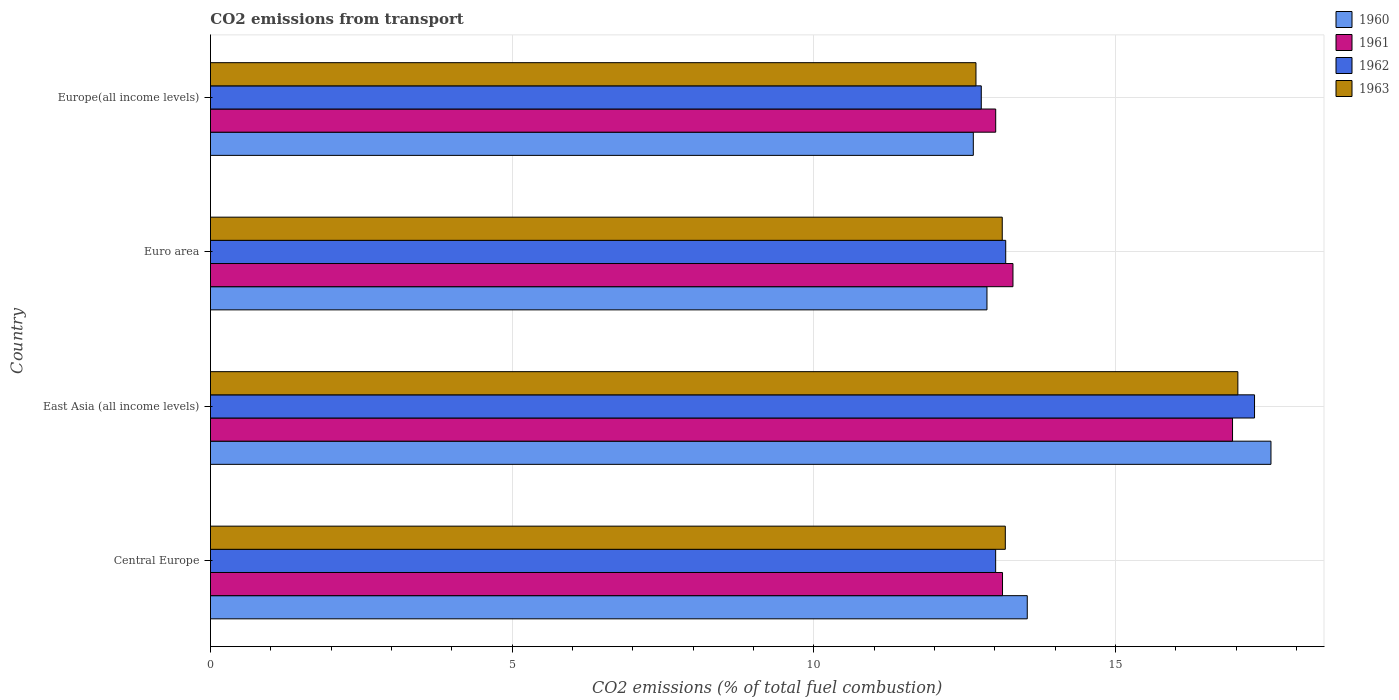Are the number of bars per tick equal to the number of legend labels?
Your answer should be very brief. Yes. How many bars are there on the 2nd tick from the bottom?
Make the answer very short. 4. What is the label of the 4th group of bars from the top?
Provide a short and direct response. Central Europe. In how many cases, is the number of bars for a given country not equal to the number of legend labels?
Your answer should be compact. 0. What is the total CO2 emitted in 1962 in Europe(all income levels)?
Your answer should be very brief. 12.78. Across all countries, what is the maximum total CO2 emitted in 1963?
Make the answer very short. 17.03. Across all countries, what is the minimum total CO2 emitted in 1962?
Ensure brevity in your answer.  12.78. In which country was the total CO2 emitted in 1960 maximum?
Your answer should be compact. East Asia (all income levels). In which country was the total CO2 emitted in 1963 minimum?
Your answer should be very brief. Europe(all income levels). What is the total total CO2 emitted in 1961 in the graph?
Make the answer very short. 56.38. What is the difference between the total CO2 emitted in 1961 in Central Europe and that in Europe(all income levels)?
Your answer should be very brief. 0.11. What is the difference between the total CO2 emitted in 1963 in Euro area and the total CO2 emitted in 1961 in Europe(all income levels)?
Your answer should be compact. 0.11. What is the average total CO2 emitted in 1963 per country?
Your answer should be compact. 14. What is the difference between the total CO2 emitted in 1961 and total CO2 emitted in 1962 in East Asia (all income levels)?
Provide a short and direct response. -0.36. In how many countries, is the total CO2 emitted in 1962 greater than 4 ?
Offer a terse response. 4. What is the ratio of the total CO2 emitted in 1961 in Euro area to that in Europe(all income levels)?
Your answer should be compact. 1.02. Is the total CO2 emitted in 1963 in East Asia (all income levels) less than that in Europe(all income levels)?
Ensure brevity in your answer.  No. What is the difference between the highest and the second highest total CO2 emitted in 1961?
Offer a terse response. 3.64. What is the difference between the highest and the lowest total CO2 emitted in 1961?
Your response must be concise. 3.93. In how many countries, is the total CO2 emitted in 1963 greater than the average total CO2 emitted in 1963 taken over all countries?
Give a very brief answer. 1. Is the sum of the total CO2 emitted in 1963 in East Asia (all income levels) and Europe(all income levels) greater than the maximum total CO2 emitted in 1961 across all countries?
Offer a very short reply. Yes. Does the graph contain grids?
Ensure brevity in your answer.  Yes. Where does the legend appear in the graph?
Make the answer very short. Top right. What is the title of the graph?
Your answer should be compact. CO2 emissions from transport. What is the label or title of the X-axis?
Your answer should be very brief. CO2 emissions (% of total fuel combustion). What is the label or title of the Y-axis?
Offer a very short reply. Country. What is the CO2 emissions (% of total fuel combustion) of 1960 in Central Europe?
Make the answer very short. 13.54. What is the CO2 emissions (% of total fuel combustion) of 1961 in Central Europe?
Offer a terse response. 13.13. What is the CO2 emissions (% of total fuel combustion) of 1962 in Central Europe?
Offer a terse response. 13.01. What is the CO2 emissions (% of total fuel combustion) in 1963 in Central Europe?
Make the answer very short. 13.17. What is the CO2 emissions (% of total fuel combustion) of 1960 in East Asia (all income levels)?
Your answer should be compact. 17.58. What is the CO2 emissions (% of total fuel combustion) of 1961 in East Asia (all income levels)?
Keep it short and to the point. 16.94. What is the CO2 emissions (% of total fuel combustion) in 1962 in East Asia (all income levels)?
Your answer should be compact. 17.3. What is the CO2 emissions (% of total fuel combustion) of 1963 in East Asia (all income levels)?
Your response must be concise. 17.03. What is the CO2 emissions (% of total fuel combustion) in 1960 in Euro area?
Offer a terse response. 12.87. What is the CO2 emissions (% of total fuel combustion) in 1961 in Euro area?
Provide a short and direct response. 13.3. What is the CO2 emissions (% of total fuel combustion) of 1962 in Euro area?
Your response must be concise. 13.18. What is the CO2 emissions (% of total fuel combustion) of 1963 in Euro area?
Keep it short and to the point. 13.12. What is the CO2 emissions (% of total fuel combustion) in 1960 in Europe(all income levels)?
Offer a very short reply. 12.64. What is the CO2 emissions (% of total fuel combustion) in 1961 in Europe(all income levels)?
Provide a succinct answer. 13.01. What is the CO2 emissions (% of total fuel combustion) of 1962 in Europe(all income levels)?
Give a very brief answer. 12.78. What is the CO2 emissions (% of total fuel combustion) of 1963 in Europe(all income levels)?
Your response must be concise. 12.69. Across all countries, what is the maximum CO2 emissions (% of total fuel combustion) of 1960?
Provide a succinct answer. 17.58. Across all countries, what is the maximum CO2 emissions (% of total fuel combustion) in 1961?
Your answer should be compact. 16.94. Across all countries, what is the maximum CO2 emissions (% of total fuel combustion) of 1962?
Your answer should be very brief. 17.3. Across all countries, what is the maximum CO2 emissions (% of total fuel combustion) in 1963?
Give a very brief answer. 17.03. Across all countries, what is the minimum CO2 emissions (% of total fuel combustion) of 1960?
Your answer should be very brief. 12.64. Across all countries, what is the minimum CO2 emissions (% of total fuel combustion) of 1961?
Keep it short and to the point. 13.01. Across all countries, what is the minimum CO2 emissions (% of total fuel combustion) of 1962?
Offer a terse response. 12.78. Across all countries, what is the minimum CO2 emissions (% of total fuel combustion) in 1963?
Provide a short and direct response. 12.69. What is the total CO2 emissions (% of total fuel combustion) of 1960 in the graph?
Provide a short and direct response. 56.63. What is the total CO2 emissions (% of total fuel combustion) of 1961 in the graph?
Provide a succinct answer. 56.38. What is the total CO2 emissions (% of total fuel combustion) in 1962 in the graph?
Provide a succinct answer. 56.28. What is the total CO2 emissions (% of total fuel combustion) of 1963 in the graph?
Make the answer very short. 56.01. What is the difference between the CO2 emissions (% of total fuel combustion) of 1960 in Central Europe and that in East Asia (all income levels)?
Your answer should be very brief. -4.04. What is the difference between the CO2 emissions (% of total fuel combustion) in 1961 in Central Europe and that in East Asia (all income levels)?
Offer a terse response. -3.81. What is the difference between the CO2 emissions (% of total fuel combustion) of 1962 in Central Europe and that in East Asia (all income levels)?
Your response must be concise. -4.29. What is the difference between the CO2 emissions (% of total fuel combustion) of 1963 in Central Europe and that in East Asia (all income levels)?
Offer a terse response. -3.85. What is the difference between the CO2 emissions (% of total fuel combustion) in 1960 in Central Europe and that in Euro area?
Your answer should be compact. 0.67. What is the difference between the CO2 emissions (% of total fuel combustion) in 1961 in Central Europe and that in Euro area?
Your answer should be compact. -0.17. What is the difference between the CO2 emissions (% of total fuel combustion) of 1962 in Central Europe and that in Euro area?
Offer a terse response. -0.17. What is the difference between the CO2 emissions (% of total fuel combustion) of 1963 in Central Europe and that in Euro area?
Ensure brevity in your answer.  0.05. What is the difference between the CO2 emissions (% of total fuel combustion) in 1960 in Central Europe and that in Europe(all income levels)?
Provide a short and direct response. 0.89. What is the difference between the CO2 emissions (% of total fuel combustion) in 1961 in Central Europe and that in Europe(all income levels)?
Give a very brief answer. 0.11. What is the difference between the CO2 emissions (% of total fuel combustion) of 1962 in Central Europe and that in Europe(all income levels)?
Keep it short and to the point. 0.24. What is the difference between the CO2 emissions (% of total fuel combustion) of 1963 in Central Europe and that in Europe(all income levels)?
Offer a very short reply. 0.49. What is the difference between the CO2 emissions (% of total fuel combustion) in 1960 in East Asia (all income levels) and that in Euro area?
Provide a succinct answer. 4.71. What is the difference between the CO2 emissions (% of total fuel combustion) in 1961 in East Asia (all income levels) and that in Euro area?
Offer a very short reply. 3.64. What is the difference between the CO2 emissions (% of total fuel combustion) in 1962 in East Asia (all income levels) and that in Euro area?
Your answer should be very brief. 4.12. What is the difference between the CO2 emissions (% of total fuel combustion) in 1963 in East Asia (all income levels) and that in Euro area?
Provide a succinct answer. 3.9. What is the difference between the CO2 emissions (% of total fuel combustion) in 1960 in East Asia (all income levels) and that in Europe(all income levels)?
Offer a very short reply. 4.93. What is the difference between the CO2 emissions (% of total fuel combustion) in 1961 in East Asia (all income levels) and that in Europe(all income levels)?
Offer a very short reply. 3.93. What is the difference between the CO2 emissions (% of total fuel combustion) of 1962 in East Asia (all income levels) and that in Europe(all income levels)?
Provide a short and direct response. 4.53. What is the difference between the CO2 emissions (% of total fuel combustion) of 1963 in East Asia (all income levels) and that in Europe(all income levels)?
Ensure brevity in your answer.  4.34. What is the difference between the CO2 emissions (% of total fuel combustion) of 1960 in Euro area and that in Europe(all income levels)?
Ensure brevity in your answer.  0.23. What is the difference between the CO2 emissions (% of total fuel combustion) of 1961 in Euro area and that in Europe(all income levels)?
Offer a very short reply. 0.29. What is the difference between the CO2 emissions (% of total fuel combustion) in 1962 in Euro area and that in Europe(all income levels)?
Offer a terse response. 0.41. What is the difference between the CO2 emissions (% of total fuel combustion) of 1963 in Euro area and that in Europe(all income levels)?
Your response must be concise. 0.44. What is the difference between the CO2 emissions (% of total fuel combustion) in 1960 in Central Europe and the CO2 emissions (% of total fuel combustion) in 1961 in East Asia (all income levels)?
Your response must be concise. -3.4. What is the difference between the CO2 emissions (% of total fuel combustion) of 1960 in Central Europe and the CO2 emissions (% of total fuel combustion) of 1962 in East Asia (all income levels)?
Make the answer very short. -3.77. What is the difference between the CO2 emissions (% of total fuel combustion) of 1960 in Central Europe and the CO2 emissions (% of total fuel combustion) of 1963 in East Asia (all income levels)?
Ensure brevity in your answer.  -3.49. What is the difference between the CO2 emissions (% of total fuel combustion) in 1961 in Central Europe and the CO2 emissions (% of total fuel combustion) in 1962 in East Asia (all income levels)?
Your answer should be compact. -4.18. What is the difference between the CO2 emissions (% of total fuel combustion) of 1961 in Central Europe and the CO2 emissions (% of total fuel combustion) of 1963 in East Asia (all income levels)?
Provide a succinct answer. -3.9. What is the difference between the CO2 emissions (% of total fuel combustion) in 1962 in Central Europe and the CO2 emissions (% of total fuel combustion) in 1963 in East Asia (all income levels)?
Your answer should be very brief. -4.01. What is the difference between the CO2 emissions (% of total fuel combustion) of 1960 in Central Europe and the CO2 emissions (% of total fuel combustion) of 1961 in Euro area?
Your response must be concise. 0.24. What is the difference between the CO2 emissions (% of total fuel combustion) of 1960 in Central Europe and the CO2 emissions (% of total fuel combustion) of 1962 in Euro area?
Your answer should be very brief. 0.36. What is the difference between the CO2 emissions (% of total fuel combustion) in 1960 in Central Europe and the CO2 emissions (% of total fuel combustion) in 1963 in Euro area?
Provide a short and direct response. 0.41. What is the difference between the CO2 emissions (% of total fuel combustion) of 1961 in Central Europe and the CO2 emissions (% of total fuel combustion) of 1962 in Euro area?
Provide a short and direct response. -0.05. What is the difference between the CO2 emissions (% of total fuel combustion) in 1961 in Central Europe and the CO2 emissions (% of total fuel combustion) in 1963 in Euro area?
Make the answer very short. 0. What is the difference between the CO2 emissions (% of total fuel combustion) in 1962 in Central Europe and the CO2 emissions (% of total fuel combustion) in 1963 in Euro area?
Provide a short and direct response. -0.11. What is the difference between the CO2 emissions (% of total fuel combustion) in 1960 in Central Europe and the CO2 emissions (% of total fuel combustion) in 1961 in Europe(all income levels)?
Keep it short and to the point. 0.52. What is the difference between the CO2 emissions (% of total fuel combustion) in 1960 in Central Europe and the CO2 emissions (% of total fuel combustion) in 1962 in Europe(all income levels)?
Provide a short and direct response. 0.76. What is the difference between the CO2 emissions (% of total fuel combustion) of 1960 in Central Europe and the CO2 emissions (% of total fuel combustion) of 1963 in Europe(all income levels)?
Ensure brevity in your answer.  0.85. What is the difference between the CO2 emissions (% of total fuel combustion) of 1961 in Central Europe and the CO2 emissions (% of total fuel combustion) of 1962 in Europe(all income levels)?
Your answer should be very brief. 0.35. What is the difference between the CO2 emissions (% of total fuel combustion) in 1961 in Central Europe and the CO2 emissions (% of total fuel combustion) in 1963 in Europe(all income levels)?
Make the answer very short. 0.44. What is the difference between the CO2 emissions (% of total fuel combustion) of 1962 in Central Europe and the CO2 emissions (% of total fuel combustion) of 1963 in Europe(all income levels)?
Offer a terse response. 0.33. What is the difference between the CO2 emissions (% of total fuel combustion) of 1960 in East Asia (all income levels) and the CO2 emissions (% of total fuel combustion) of 1961 in Euro area?
Provide a succinct answer. 4.28. What is the difference between the CO2 emissions (% of total fuel combustion) of 1960 in East Asia (all income levels) and the CO2 emissions (% of total fuel combustion) of 1962 in Euro area?
Provide a short and direct response. 4.4. What is the difference between the CO2 emissions (% of total fuel combustion) in 1960 in East Asia (all income levels) and the CO2 emissions (% of total fuel combustion) in 1963 in Euro area?
Give a very brief answer. 4.45. What is the difference between the CO2 emissions (% of total fuel combustion) in 1961 in East Asia (all income levels) and the CO2 emissions (% of total fuel combustion) in 1962 in Euro area?
Make the answer very short. 3.76. What is the difference between the CO2 emissions (% of total fuel combustion) of 1961 in East Asia (all income levels) and the CO2 emissions (% of total fuel combustion) of 1963 in Euro area?
Your response must be concise. 3.82. What is the difference between the CO2 emissions (% of total fuel combustion) of 1962 in East Asia (all income levels) and the CO2 emissions (% of total fuel combustion) of 1963 in Euro area?
Provide a short and direct response. 4.18. What is the difference between the CO2 emissions (% of total fuel combustion) of 1960 in East Asia (all income levels) and the CO2 emissions (% of total fuel combustion) of 1961 in Europe(all income levels)?
Your answer should be compact. 4.56. What is the difference between the CO2 emissions (% of total fuel combustion) of 1960 in East Asia (all income levels) and the CO2 emissions (% of total fuel combustion) of 1962 in Europe(all income levels)?
Keep it short and to the point. 4.8. What is the difference between the CO2 emissions (% of total fuel combustion) in 1960 in East Asia (all income levels) and the CO2 emissions (% of total fuel combustion) in 1963 in Europe(all income levels)?
Provide a succinct answer. 4.89. What is the difference between the CO2 emissions (% of total fuel combustion) of 1961 in East Asia (all income levels) and the CO2 emissions (% of total fuel combustion) of 1962 in Europe(all income levels)?
Your answer should be very brief. 4.16. What is the difference between the CO2 emissions (% of total fuel combustion) of 1961 in East Asia (all income levels) and the CO2 emissions (% of total fuel combustion) of 1963 in Europe(all income levels)?
Offer a terse response. 4.25. What is the difference between the CO2 emissions (% of total fuel combustion) of 1962 in East Asia (all income levels) and the CO2 emissions (% of total fuel combustion) of 1963 in Europe(all income levels)?
Your answer should be compact. 4.62. What is the difference between the CO2 emissions (% of total fuel combustion) of 1960 in Euro area and the CO2 emissions (% of total fuel combustion) of 1961 in Europe(all income levels)?
Offer a very short reply. -0.14. What is the difference between the CO2 emissions (% of total fuel combustion) in 1960 in Euro area and the CO2 emissions (% of total fuel combustion) in 1962 in Europe(all income levels)?
Provide a short and direct response. 0.09. What is the difference between the CO2 emissions (% of total fuel combustion) in 1960 in Euro area and the CO2 emissions (% of total fuel combustion) in 1963 in Europe(all income levels)?
Offer a terse response. 0.18. What is the difference between the CO2 emissions (% of total fuel combustion) in 1961 in Euro area and the CO2 emissions (% of total fuel combustion) in 1962 in Europe(all income levels)?
Give a very brief answer. 0.53. What is the difference between the CO2 emissions (% of total fuel combustion) in 1961 in Euro area and the CO2 emissions (% of total fuel combustion) in 1963 in Europe(all income levels)?
Provide a succinct answer. 0.61. What is the difference between the CO2 emissions (% of total fuel combustion) of 1962 in Euro area and the CO2 emissions (% of total fuel combustion) of 1963 in Europe(all income levels)?
Provide a short and direct response. 0.49. What is the average CO2 emissions (% of total fuel combustion) in 1960 per country?
Provide a short and direct response. 14.16. What is the average CO2 emissions (% of total fuel combustion) in 1961 per country?
Offer a terse response. 14.1. What is the average CO2 emissions (% of total fuel combustion) in 1962 per country?
Offer a very short reply. 14.07. What is the average CO2 emissions (% of total fuel combustion) of 1963 per country?
Your response must be concise. 14. What is the difference between the CO2 emissions (% of total fuel combustion) of 1960 and CO2 emissions (% of total fuel combustion) of 1961 in Central Europe?
Your answer should be compact. 0.41. What is the difference between the CO2 emissions (% of total fuel combustion) of 1960 and CO2 emissions (% of total fuel combustion) of 1962 in Central Europe?
Keep it short and to the point. 0.52. What is the difference between the CO2 emissions (% of total fuel combustion) in 1960 and CO2 emissions (% of total fuel combustion) in 1963 in Central Europe?
Your answer should be compact. 0.36. What is the difference between the CO2 emissions (% of total fuel combustion) in 1961 and CO2 emissions (% of total fuel combustion) in 1962 in Central Europe?
Your answer should be very brief. 0.11. What is the difference between the CO2 emissions (% of total fuel combustion) in 1961 and CO2 emissions (% of total fuel combustion) in 1963 in Central Europe?
Ensure brevity in your answer.  -0.05. What is the difference between the CO2 emissions (% of total fuel combustion) of 1962 and CO2 emissions (% of total fuel combustion) of 1963 in Central Europe?
Make the answer very short. -0.16. What is the difference between the CO2 emissions (% of total fuel combustion) in 1960 and CO2 emissions (% of total fuel combustion) in 1961 in East Asia (all income levels)?
Ensure brevity in your answer.  0.64. What is the difference between the CO2 emissions (% of total fuel combustion) of 1960 and CO2 emissions (% of total fuel combustion) of 1962 in East Asia (all income levels)?
Offer a very short reply. 0.27. What is the difference between the CO2 emissions (% of total fuel combustion) of 1960 and CO2 emissions (% of total fuel combustion) of 1963 in East Asia (all income levels)?
Offer a terse response. 0.55. What is the difference between the CO2 emissions (% of total fuel combustion) in 1961 and CO2 emissions (% of total fuel combustion) in 1962 in East Asia (all income levels)?
Offer a terse response. -0.36. What is the difference between the CO2 emissions (% of total fuel combustion) in 1961 and CO2 emissions (% of total fuel combustion) in 1963 in East Asia (all income levels)?
Give a very brief answer. -0.09. What is the difference between the CO2 emissions (% of total fuel combustion) of 1962 and CO2 emissions (% of total fuel combustion) of 1963 in East Asia (all income levels)?
Make the answer very short. 0.28. What is the difference between the CO2 emissions (% of total fuel combustion) in 1960 and CO2 emissions (% of total fuel combustion) in 1961 in Euro area?
Give a very brief answer. -0.43. What is the difference between the CO2 emissions (% of total fuel combustion) in 1960 and CO2 emissions (% of total fuel combustion) in 1962 in Euro area?
Your answer should be compact. -0.31. What is the difference between the CO2 emissions (% of total fuel combustion) in 1960 and CO2 emissions (% of total fuel combustion) in 1963 in Euro area?
Offer a terse response. -0.25. What is the difference between the CO2 emissions (% of total fuel combustion) of 1961 and CO2 emissions (% of total fuel combustion) of 1962 in Euro area?
Give a very brief answer. 0.12. What is the difference between the CO2 emissions (% of total fuel combustion) in 1961 and CO2 emissions (% of total fuel combustion) in 1963 in Euro area?
Ensure brevity in your answer.  0.18. What is the difference between the CO2 emissions (% of total fuel combustion) in 1962 and CO2 emissions (% of total fuel combustion) in 1963 in Euro area?
Keep it short and to the point. 0.06. What is the difference between the CO2 emissions (% of total fuel combustion) in 1960 and CO2 emissions (% of total fuel combustion) in 1961 in Europe(all income levels)?
Make the answer very short. -0.37. What is the difference between the CO2 emissions (% of total fuel combustion) in 1960 and CO2 emissions (% of total fuel combustion) in 1962 in Europe(all income levels)?
Your answer should be compact. -0.13. What is the difference between the CO2 emissions (% of total fuel combustion) in 1960 and CO2 emissions (% of total fuel combustion) in 1963 in Europe(all income levels)?
Your response must be concise. -0.04. What is the difference between the CO2 emissions (% of total fuel combustion) in 1961 and CO2 emissions (% of total fuel combustion) in 1962 in Europe(all income levels)?
Give a very brief answer. 0.24. What is the difference between the CO2 emissions (% of total fuel combustion) in 1961 and CO2 emissions (% of total fuel combustion) in 1963 in Europe(all income levels)?
Give a very brief answer. 0.33. What is the difference between the CO2 emissions (% of total fuel combustion) in 1962 and CO2 emissions (% of total fuel combustion) in 1963 in Europe(all income levels)?
Your answer should be compact. 0.09. What is the ratio of the CO2 emissions (% of total fuel combustion) of 1960 in Central Europe to that in East Asia (all income levels)?
Make the answer very short. 0.77. What is the ratio of the CO2 emissions (% of total fuel combustion) in 1961 in Central Europe to that in East Asia (all income levels)?
Offer a very short reply. 0.77. What is the ratio of the CO2 emissions (% of total fuel combustion) of 1962 in Central Europe to that in East Asia (all income levels)?
Make the answer very short. 0.75. What is the ratio of the CO2 emissions (% of total fuel combustion) of 1963 in Central Europe to that in East Asia (all income levels)?
Your answer should be compact. 0.77. What is the ratio of the CO2 emissions (% of total fuel combustion) of 1960 in Central Europe to that in Euro area?
Offer a very short reply. 1.05. What is the ratio of the CO2 emissions (% of total fuel combustion) of 1961 in Central Europe to that in Euro area?
Offer a terse response. 0.99. What is the ratio of the CO2 emissions (% of total fuel combustion) in 1962 in Central Europe to that in Euro area?
Offer a very short reply. 0.99. What is the ratio of the CO2 emissions (% of total fuel combustion) in 1960 in Central Europe to that in Europe(all income levels)?
Your response must be concise. 1.07. What is the ratio of the CO2 emissions (% of total fuel combustion) in 1961 in Central Europe to that in Europe(all income levels)?
Keep it short and to the point. 1.01. What is the ratio of the CO2 emissions (% of total fuel combustion) in 1962 in Central Europe to that in Europe(all income levels)?
Your answer should be compact. 1.02. What is the ratio of the CO2 emissions (% of total fuel combustion) of 1963 in Central Europe to that in Europe(all income levels)?
Give a very brief answer. 1.04. What is the ratio of the CO2 emissions (% of total fuel combustion) in 1960 in East Asia (all income levels) to that in Euro area?
Keep it short and to the point. 1.37. What is the ratio of the CO2 emissions (% of total fuel combustion) in 1961 in East Asia (all income levels) to that in Euro area?
Ensure brevity in your answer.  1.27. What is the ratio of the CO2 emissions (% of total fuel combustion) in 1962 in East Asia (all income levels) to that in Euro area?
Your response must be concise. 1.31. What is the ratio of the CO2 emissions (% of total fuel combustion) of 1963 in East Asia (all income levels) to that in Euro area?
Ensure brevity in your answer.  1.3. What is the ratio of the CO2 emissions (% of total fuel combustion) of 1960 in East Asia (all income levels) to that in Europe(all income levels)?
Keep it short and to the point. 1.39. What is the ratio of the CO2 emissions (% of total fuel combustion) of 1961 in East Asia (all income levels) to that in Europe(all income levels)?
Keep it short and to the point. 1.3. What is the ratio of the CO2 emissions (% of total fuel combustion) of 1962 in East Asia (all income levels) to that in Europe(all income levels)?
Offer a terse response. 1.35. What is the ratio of the CO2 emissions (% of total fuel combustion) in 1963 in East Asia (all income levels) to that in Europe(all income levels)?
Provide a short and direct response. 1.34. What is the ratio of the CO2 emissions (% of total fuel combustion) of 1960 in Euro area to that in Europe(all income levels)?
Ensure brevity in your answer.  1.02. What is the ratio of the CO2 emissions (% of total fuel combustion) in 1962 in Euro area to that in Europe(all income levels)?
Keep it short and to the point. 1.03. What is the ratio of the CO2 emissions (% of total fuel combustion) of 1963 in Euro area to that in Europe(all income levels)?
Offer a terse response. 1.03. What is the difference between the highest and the second highest CO2 emissions (% of total fuel combustion) of 1960?
Offer a very short reply. 4.04. What is the difference between the highest and the second highest CO2 emissions (% of total fuel combustion) in 1961?
Provide a short and direct response. 3.64. What is the difference between the highest and the second highest CO2 emissions (% of total fuel combustion) in 1962?
Your answer should be very brief. 4.12. What is the difference between the highest and the second highest CO2 emissions (% of total fuel combustion) of 1963?
Ensure brevity in your answer.  3.85. What is the difference between the highest and the lowest CO2 emissions (% of total fuel combustion) of 1960?
Offer a terse response. 4.93. What is the difference between the highest and the lowest CO2 emissions (% of total fuel combustion) of 1961?
Keep it short and to the point. 3.93. What is the difference between the highest and the lowest CO2 emissions (% of total fuel combustion) of 1962?
Keep it short and to the point. 4.53. What is the difference between the highest and the lowest CO2 emissions (% of total fuel combustion) in 1963?
Your response must be concise. 4.34. 